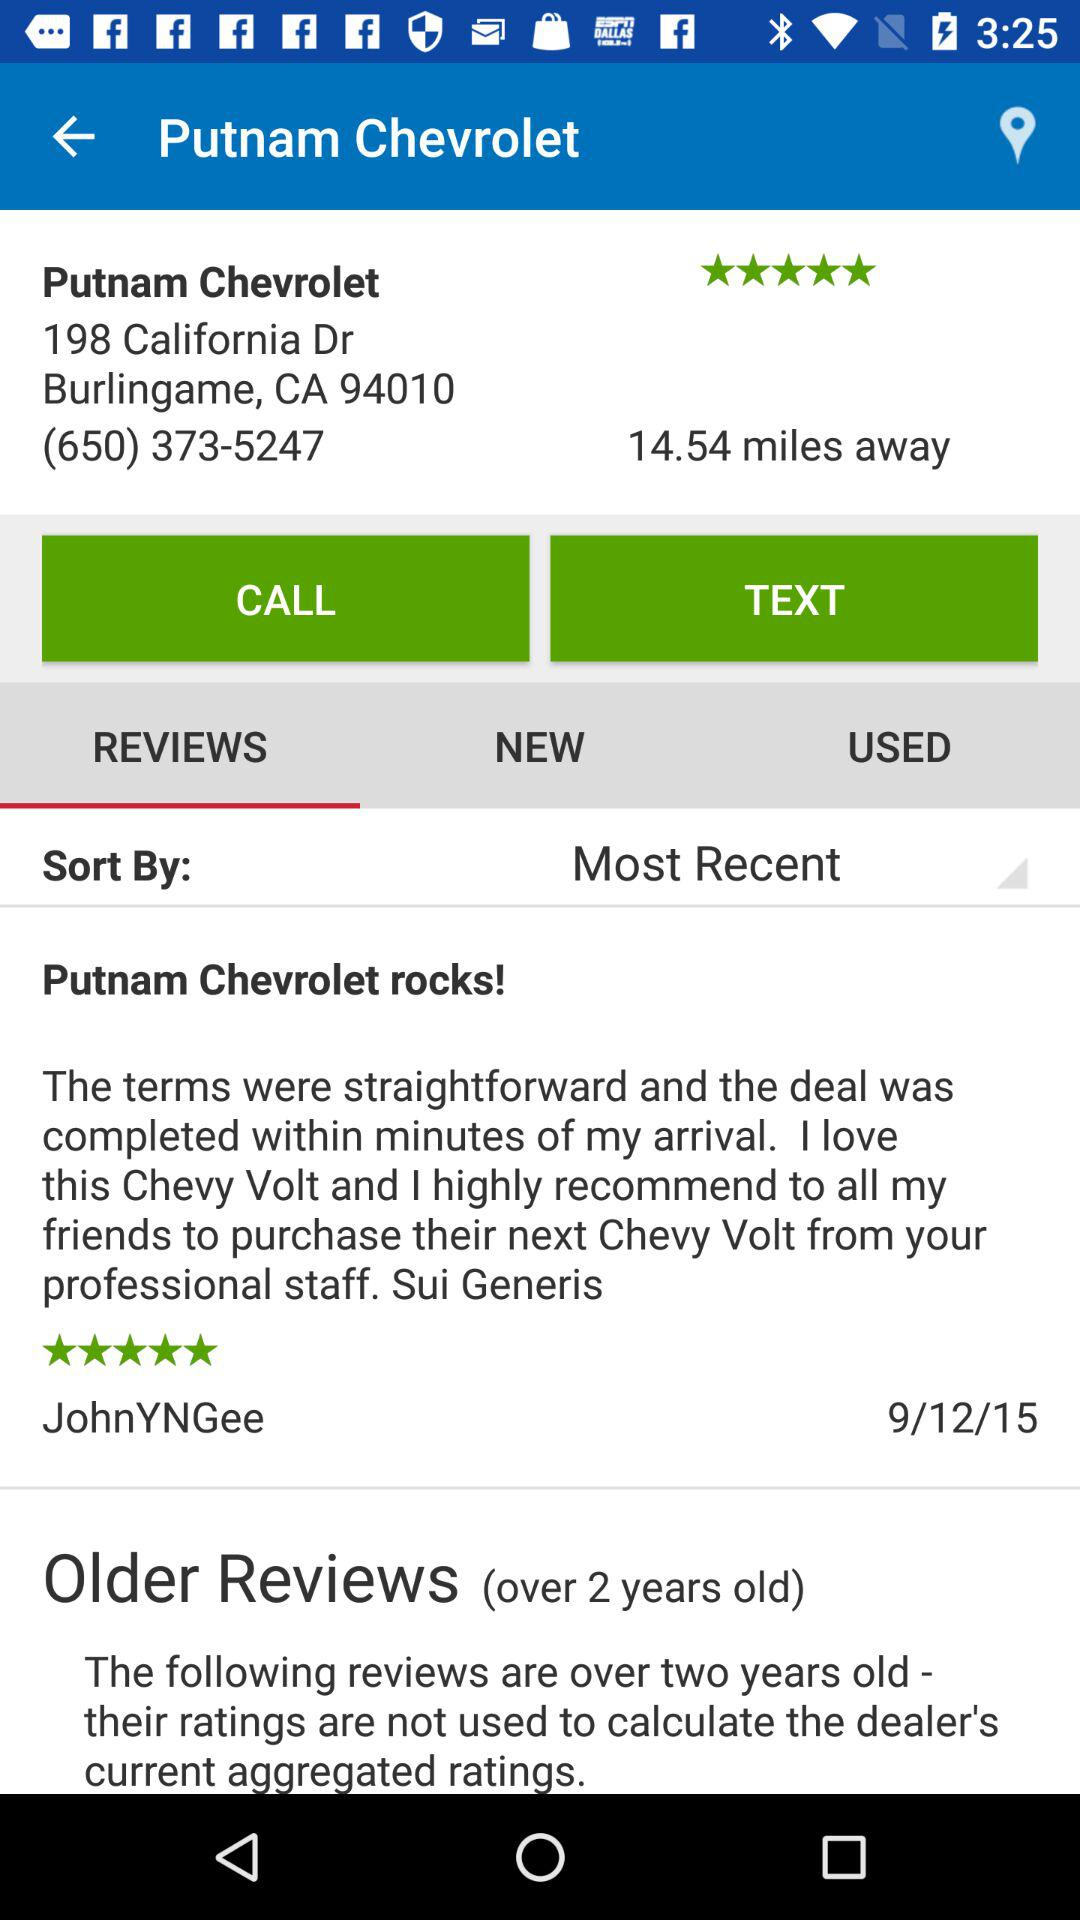On what date did JohnYNGee update a review? JohnYNGee updated a review on 9/12/15. 